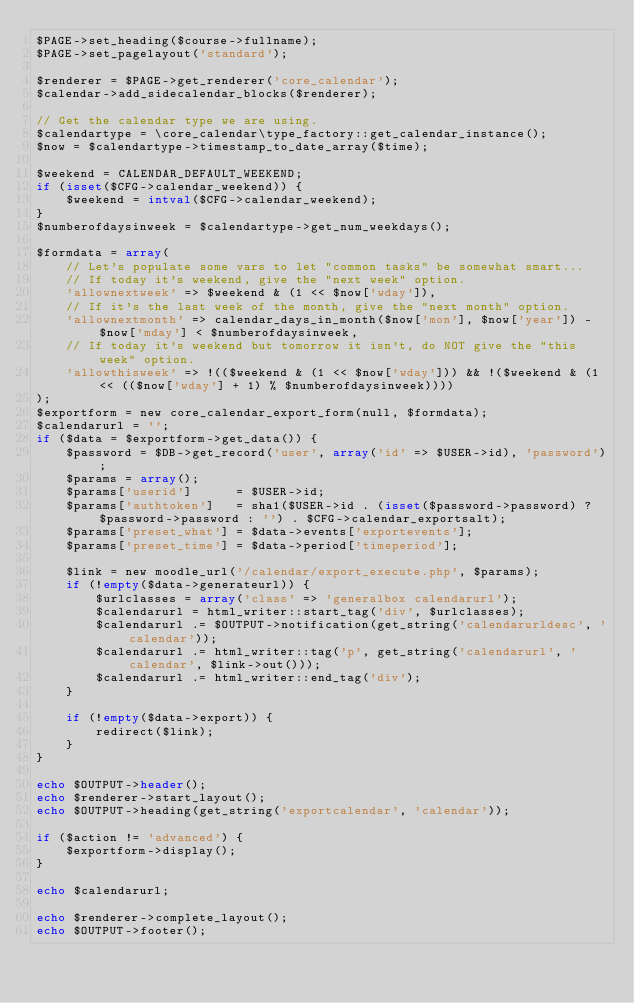<code> <loc_0><loc_0><loc_500><loc_500><_PHP_>$PAGE->set_heading($course->fullname);
$PAGE->set_pagelayout('standard');

$renderer = $PAGE->get_renderer('core_calendar');
$calendar->add_sidecalendar_blocks($renderer);

// Get the calendar type we are using.
$calendartype = \core_calendar\type_factory::get_calendar_instance();
$now = $calendartype->timestamp_to_date_array($time);

$weekend = CALENDAR_DEFAULT_WEEKEND;
if (isset($CFG->calendar_weekend)) {
    $weekend = intval($CFG->calendar_weekend);
}
$numberofdaysinweek = $calendartype->get_num_weekdays();

$formdata = array(
    // Let's populate some vars to let "common tasks" be somewhat smart...
    // If today it's weekend, give the "next week" option.
    'allownextweek' => $weekend & (1 << $now['wday']),
    // If it's the last week of the month, give the "next month" option.
    'allownextmonth' => calendar_days_in_month($now['mon'], $now['year']) - $now['mday'] < $numberofdaysinweek,
    // If today it's weekend but tomorrow it isn't, do NOT give the "this week" option.
    'allowthisweek' => !(($weekend & (1 << $now['wday'])) && !($weekend & (1 << (($now['wday'] + 1) % $numberofdaysinweek))))
);
$exportform = new core_calendar_export_form(null, $formdata);
$calendarurl = '';
if ($data = $exportform->get_data()) {
    $password = $DB->get_record('user', array('id' => $USER->id), 'password');
    $params = array();
    $params['userid']      = $USER->id;
    $params['authtoken']   = sha1($USER->id . (isset($password->password) ? $password->password : '') . $CFG->calendar_exportsalt);
    $params['preset_what'] = $data->events['exportevents'];
    $params['preset_time'] = $data->period['timeperiod'];

    $link = new moodle_url('/calendar/export_execute.php', $params);
    if (!empty($data->generateurl)) {
        $urlclasses = array('class' => 'generalbox calendarurl');
        $calendarurl = html_writer::start_tag('div', $urlclasses);
        $calendarurl .= $OUTPUT->notification(get_string('calendarurldesc', 'calendar'));
        $calendarurl .= html_writer::tag('p', get_string('calendarurl', 'calendar', $link->out()));
        $calendarurl .= html_writer::end_tag('div');
    }

    if (!empty($data->export)) {
        redirect($link);
    }
}

echo $OUTPUT->header();
echo $renderer->start_layout();
echo $OUTPUT->heading(get_string('exportcalendar', 'calendar'));

if ($action != 'advanced') {
    $exportform->display();
}

echo $calendarurl;

echo $renderer->complete_layout();
echo $OUTPUT->footer();
</code> 